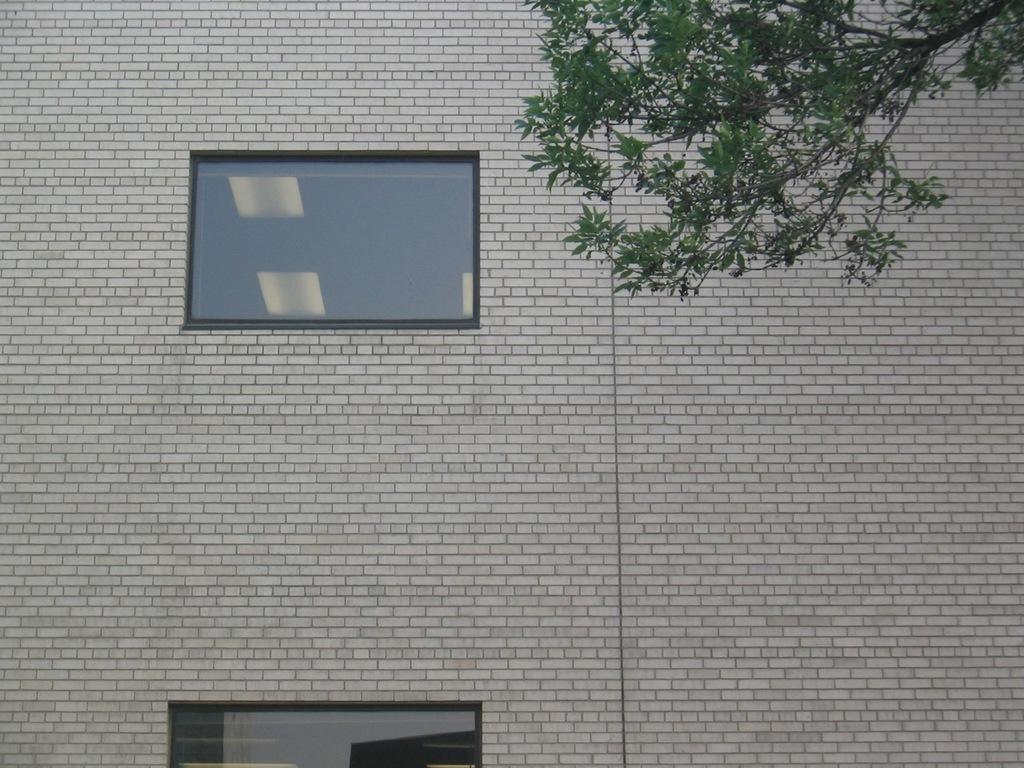In one or two sentences, can you explain what this image depicts? The picture consists of a brick wall. In the center of the picture there are glass windows. On the right there is a stem of a tree. 